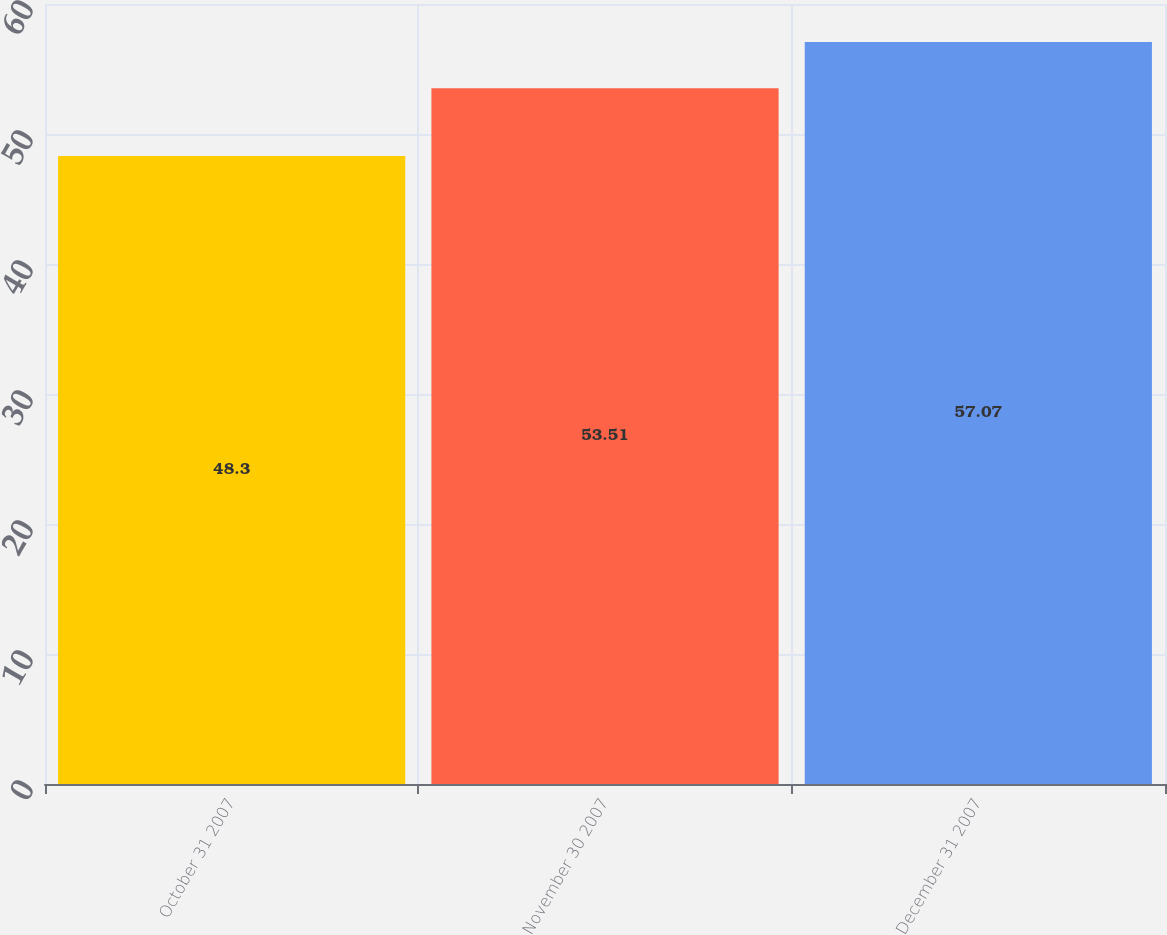<chart> <loc_0><loc_0><loc_500><loc_500><bar_chart><fcel>October 31 2007<fcel>November 30 2007<fcel>December 31 2007<nl><fcel>48.3<fcel>53.51<fcel>57.07<nl></chart> 